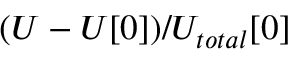<formula> <loc_0><loc_0><loc_500><loc_500>( U - U [ 0 ] ) / U _ { t o t a l } [ 0 ]</formula> 